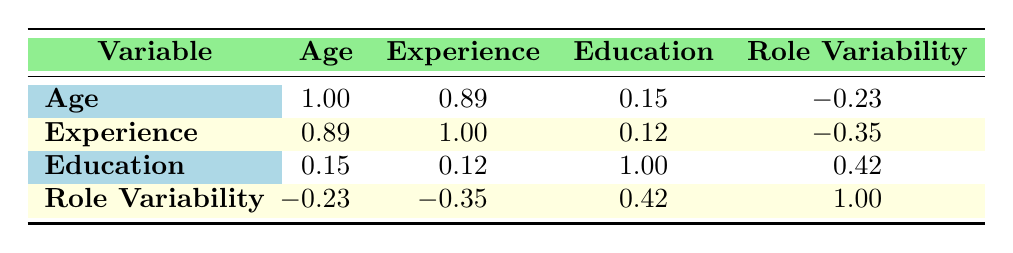What is the correlation between age and years of experience? The table indicates that the correlation coefficient between age and years of experience is 0.89, suggesting a strong positive correlation. This means that as age increases, years of experience tends to increase as well.
Answer: 0.89 What is the correlation between role variability and education level? The table shows that the correlation coefficient between role variability and education level is 0.42. This signifies a moderate positive correlation, indicating that higher education levels may be associated with greater role variability among roadies.
Answer: 0.42 Is there a negative correlation between role variability and years of experience? The correlation coefficient between role variability and years of experience is -0.35, indicating a negative correlation. This means that as the years of experience increase, the role variability tends to decrease.
Answer: Yes What is the average correlation value of education and role variability? The correlation value between education and role variability is 0.42, so the average in this case is simply 0.42 since there are no other correlations considered with respect to education alone in this context.
Answer: 0.42 Which demographic factor appears to have the strongest correlation with age? The table indicates that years of experience has the strongest correlation with age at 0.89, demonstrating that there is a notable relationship between these two variables.
Answer: Years of experience What is the correlation between experience and education? The correlation coefficient between experience and education is 0.12, indicating a very weak positive correlation between the two variables. This suggests that years of experience do not strongly relate to the level of education attained by roadies.
Answer: 0.12 Is the correlation between role variability and age significant? With a correlation coefficient of -0.23, this suggests a slight negative correlation, which is relatively low and thus not considered significant in the context of the correlations provided.
Answer: No What is the difference in correlation values between age and role variability compared to experience and role variability? The correlation between age and role variability is -0.23, while between experience and role variability it is -0.35. The difference between -0.35 and -0.23 is -0.12, indicating that the negative association is stronger for experience than for age.
Answer: -0.12 